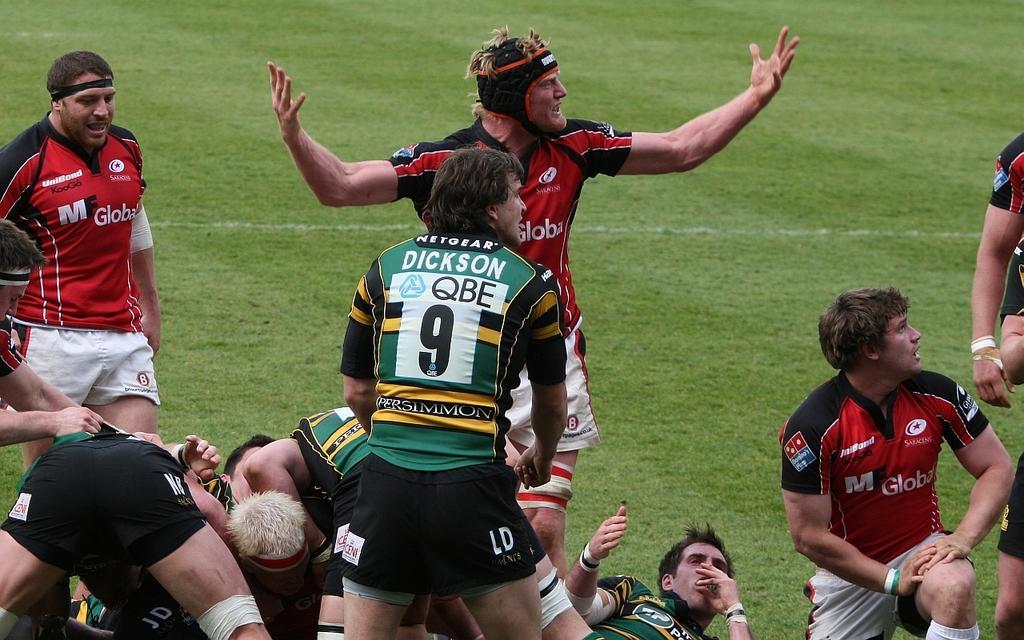Could you give a brief overview of what you see in this image? This picture might be taken inside a playground. In this image, on the right side, we can see group of people and one man is in squat position. On the left side, we can see a man walking. In the middle of the image, we can see two men are standing and group of people are lying. In the background, we can see a grass. 